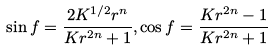<formula> <loc_0><loc_0><loc_500><loc_500>\sin f = \frac { 2 K ^ { 1 / 2 } r ^ { n } } { K r ^ { 2 n } + 1 } , \cos f = \frac { K r ^ { 2 n } - 1 } { K r ^ { 2 n } + 1 }</formula> 